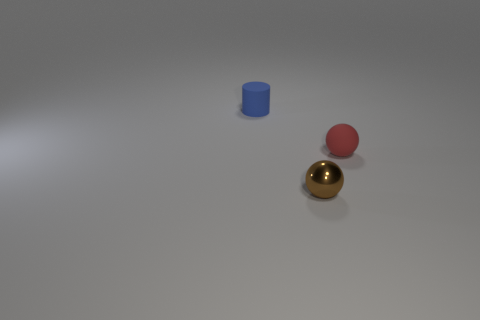There is a thing behind the tiny matte thing that is in front of the small blue matte thing; what is its material?
Provide a succinct answer. Rubber. Is the number of rubber things to the right of the blue object greater than the number of big yellow metallic blocks?
Give a very brief answer. Yes. How many other things are the same size as the brown object?
Your response must be concise. 2. What is the color of the tiny sphere left of the rubber object that is in front of the tiny object behind the small red rubber thing?
Keep it short and to the point. Brown. What number of cylinders are behind the ball that is to the right of the ball that is left of the red matte sphere?
Ensure brevity in your answer.  1. There is a small sphere that is to the right of the tiny metallic ball; what number of blue rubber objects are on the left side of it?
Keep it short and to the point. 1. There is a blue matte object that is on the left side of the tiny ball that is to the left of the small red ball; is there a red object right of it?
Your response must be concise. Yes. There is a red object that is the same shape as the brown metal thing; what is it made of?
Your response must be concise. Rubber. Is there anything else that has the same material as the small brown sphere?
Your answer should be very brief. No. Is the cylinder made of the same material as the small ball that is to the left of the small rubber sphere?
Offer a very short reply. No. 